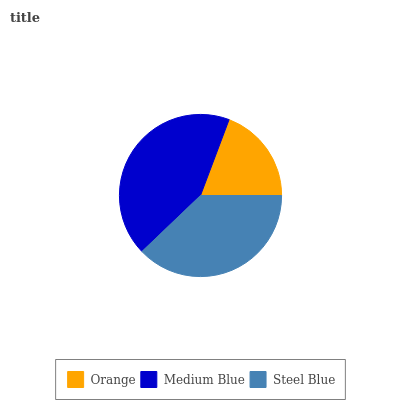Is Orange the minimum?
Answer yes or no. Yes. Is Medium Blue the maximum?
Answer yes or no. Yes. Is Steel Blue the minimum?
Answer yes or no. No. Is Steel Blue the maximum?
Answer yes or no. No. Is Medium Blue greater than Steel Blue?
Answer yes or no. Yes. Is Steel Blue less than Medium Blue?
Answer yes or no. Yes. Is Steel Blue greater than Medium Blue?
Answer yes or no. No. Is Medium Blue less than Steel Blue?
Answer yes or no. No. Is Steel Blue the high median?
Answer yes or no. Yes. Is Steel Blue the low median?
Answer yes or no. Yes. Is Orange the high median?
Answer yes or no. No. Is Orange the low median?
Answer yes or no. No. 